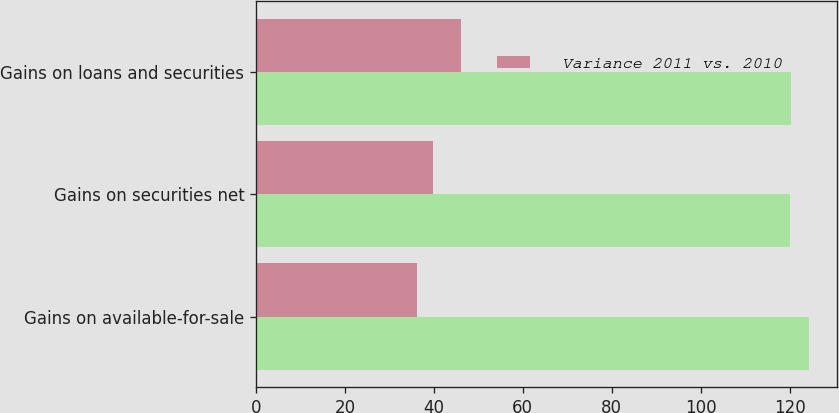Convert chart to OTSL. <chart><loc_0><loc_0><loc_500><loc_500><stacked_bar_chart><ecel><fcel>Gains on available-for-sale<fcel>Gains on securities net<fcel>Gains on loans and securities<nl><fcel>nan<fcel>124.4<fcel>120.1<fcel>120.2<nl><fcel>Variance 2011 vs. 2010<fcel>36.3<fcel>39.8<fcel>46<nl></chart> 